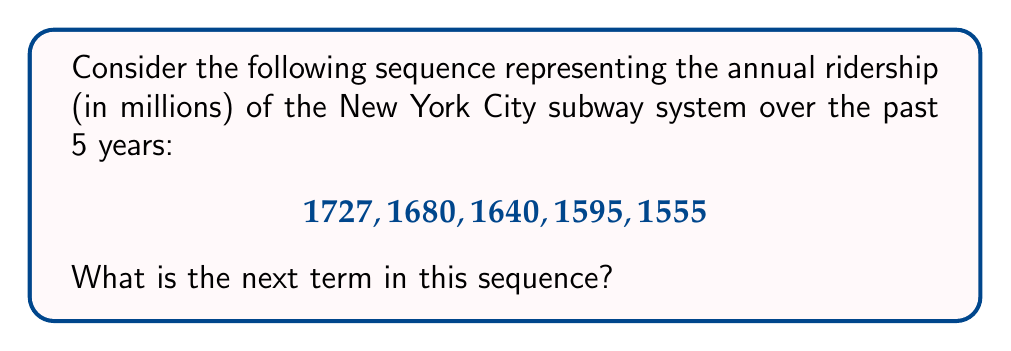Help me with this question. To find the next term in this sequence, we need to identify the pattern. Let's analyze the differences between consecutive terms:

1. $1727 - 1680 = 47$
2. $1680 - 1640 = 40$
3. $1640 - 1595 = 45$
4. $1595 - 1555 = 40$

We can observe that the ridership is decreasing each year, but not at a constant rate. The differences alternate between 40 and 45 (approximately).

Given this pattern, we can expect the next difference to be around 45. To be more precise, let's calculate the average decrease:

$\frac{47 + 40 + 45 + 40}{4} = 43$

Now, we can subtract this average decrease from the last term in the sequence:

$1555 - 43 = 1512$

Therefore, the next term in the sequence, representing the projected annual ridership for the upcoming year, would be approximately 1512 million passengers.
Answer: 1512 